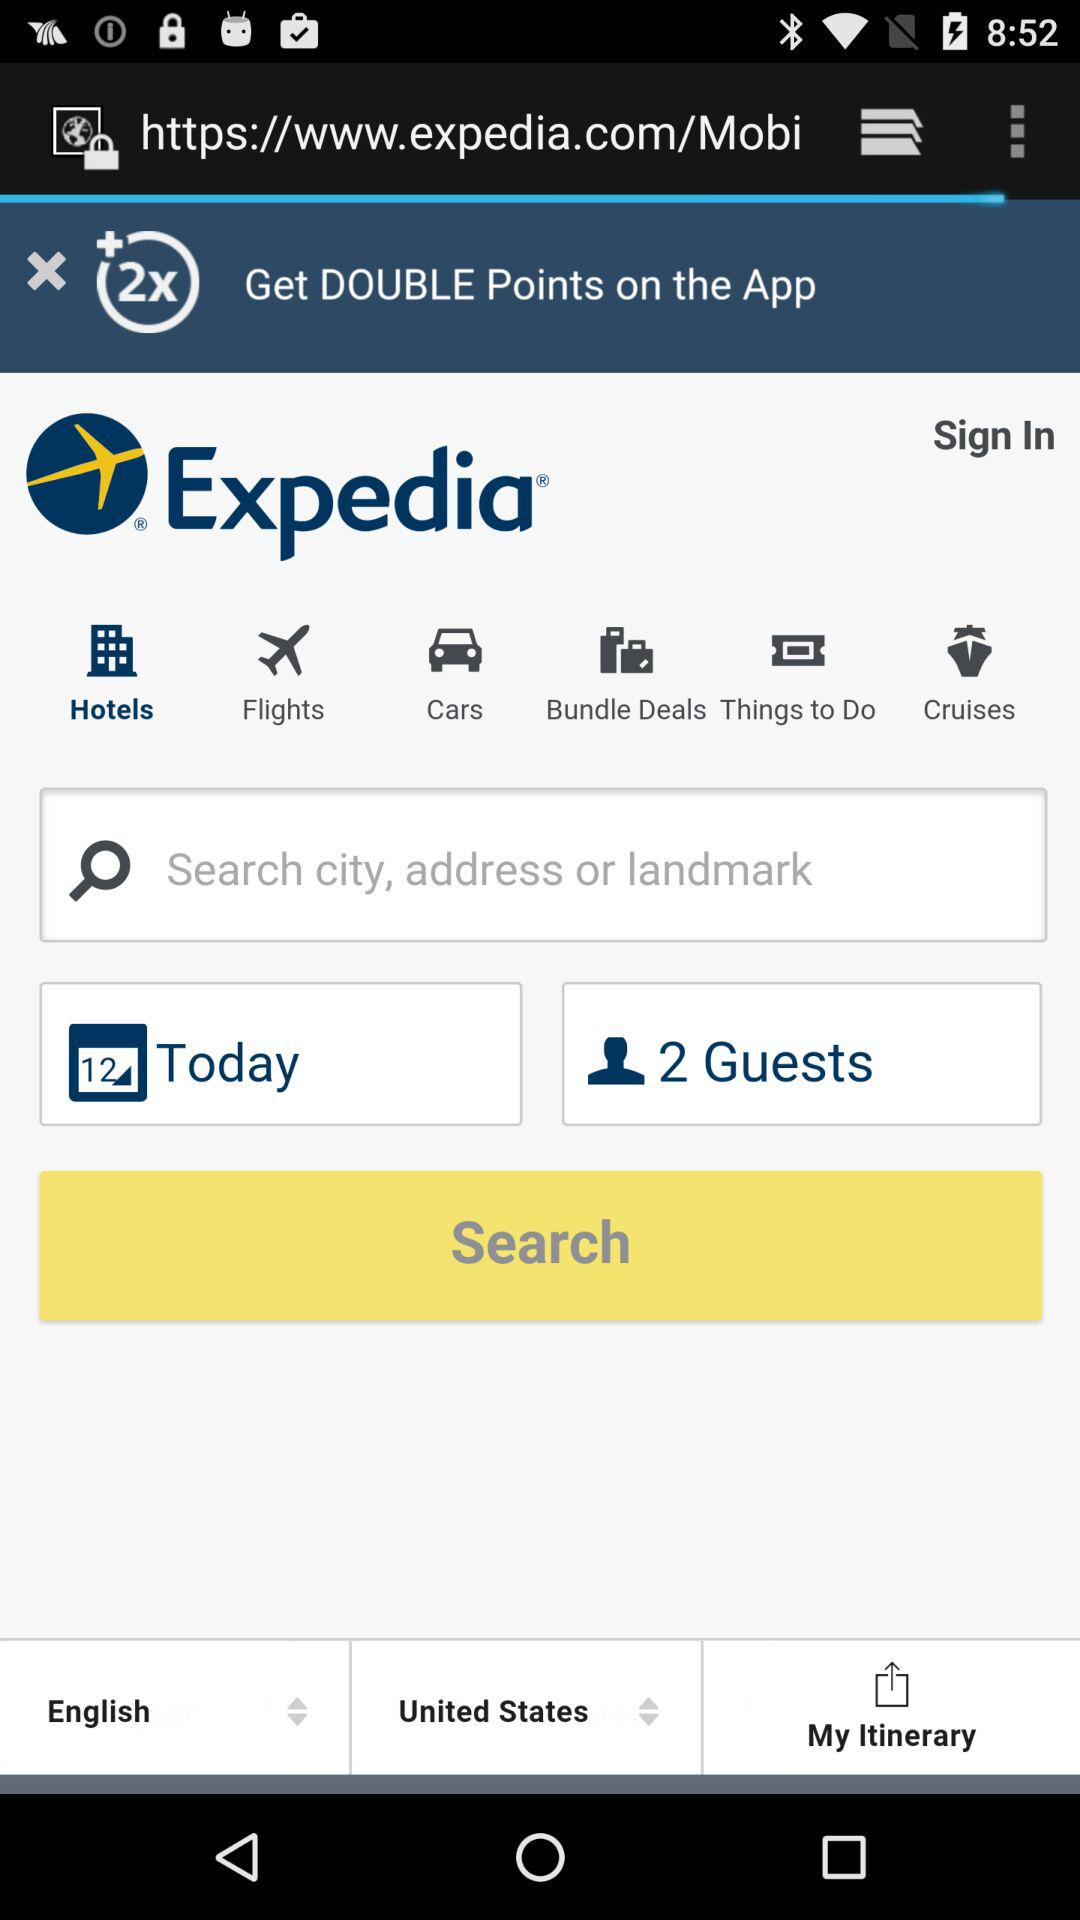Which date is selected on the calendar? The selected date is 12. 